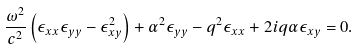<formula> <loc_0><loc_0><loc_500><loc_500>\frac { \omega ^ { 2 } } { c ^ { 2 } } \left ( \epsilon _ { x x } \epsilon _ { y y } - \epsilon _ { x y } ^ { 2 } \right ) + \alpha ^ { 2 } \epsilon _ { y y } - q ^ { 2 } \epsilon _ { x x } + 2 i q \alpha \epsilon _ { x y } = 0 .</formula> 